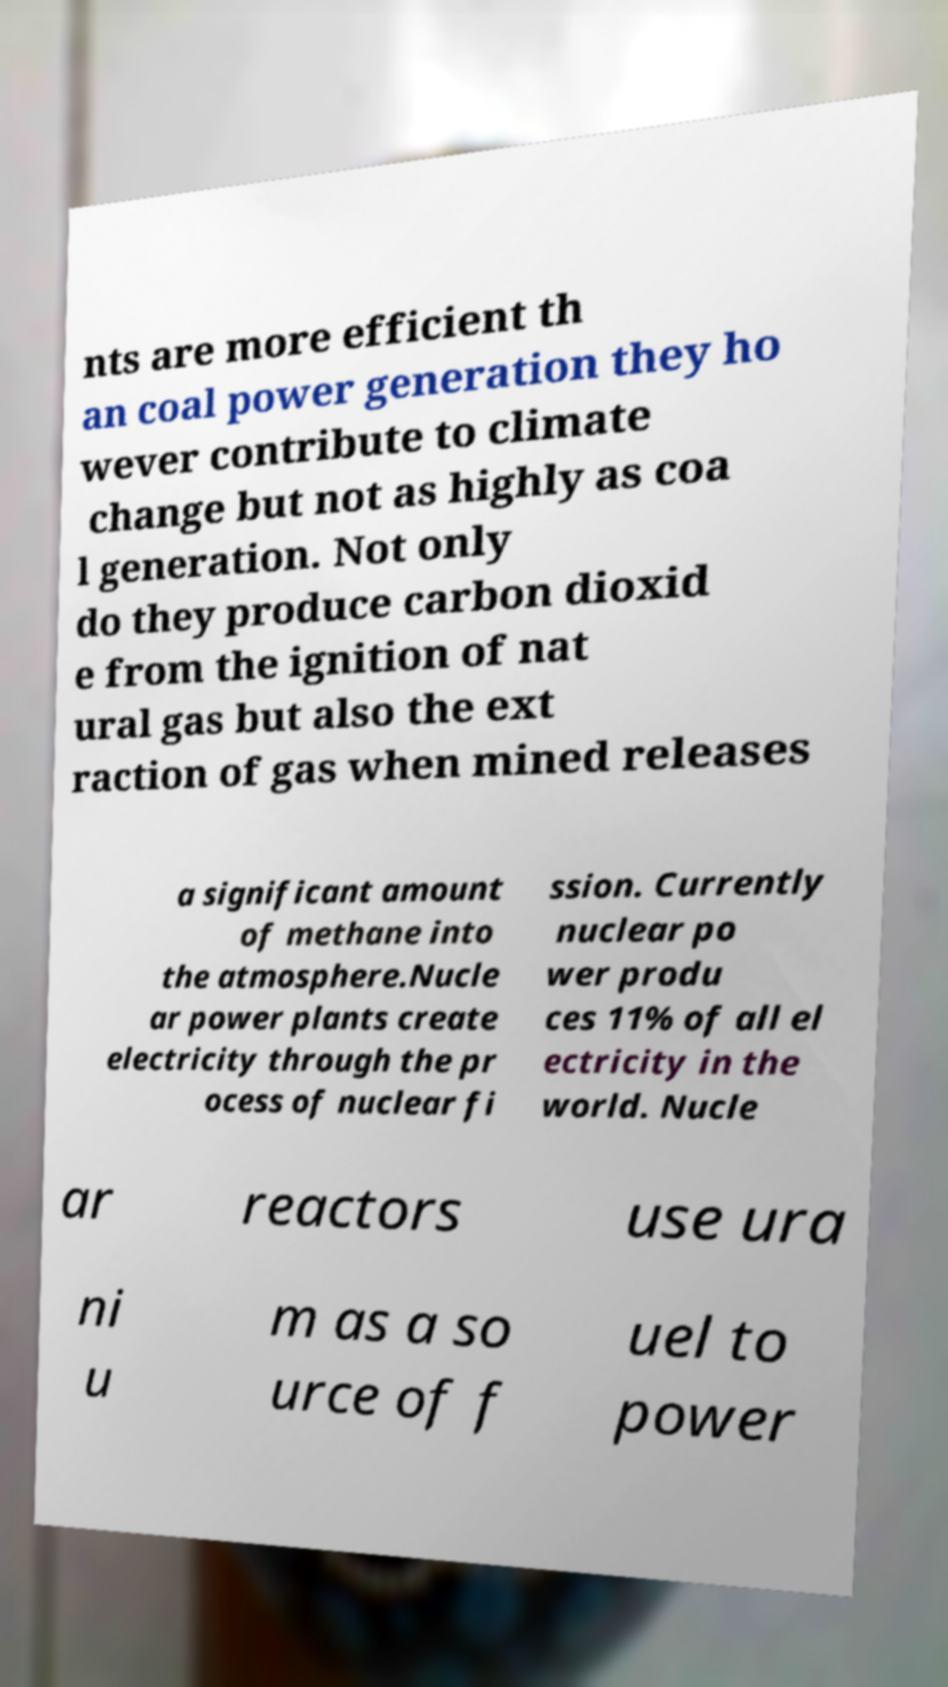Can you read and provide the text displayed in the image?This photo seems to have some interesting text. Can you extract and type it out for me? nts are more efficient th an coal power generation they ho wever contribute to climate change but not as highly as coa l generation. Not only do they produce carbon dioxid e from the ignition of nat ural gas but also the ext raction of gas when mined releases a significant amount of methane into the atmosphere.Nucle ar power plants create electricity through the pr ocess of nuclear fi ssion. Currently nuclear po wer produ ces 11% of all el ectricity in the world. Nucle ar reactors use ura ni u m as a so urce of f uel to power 